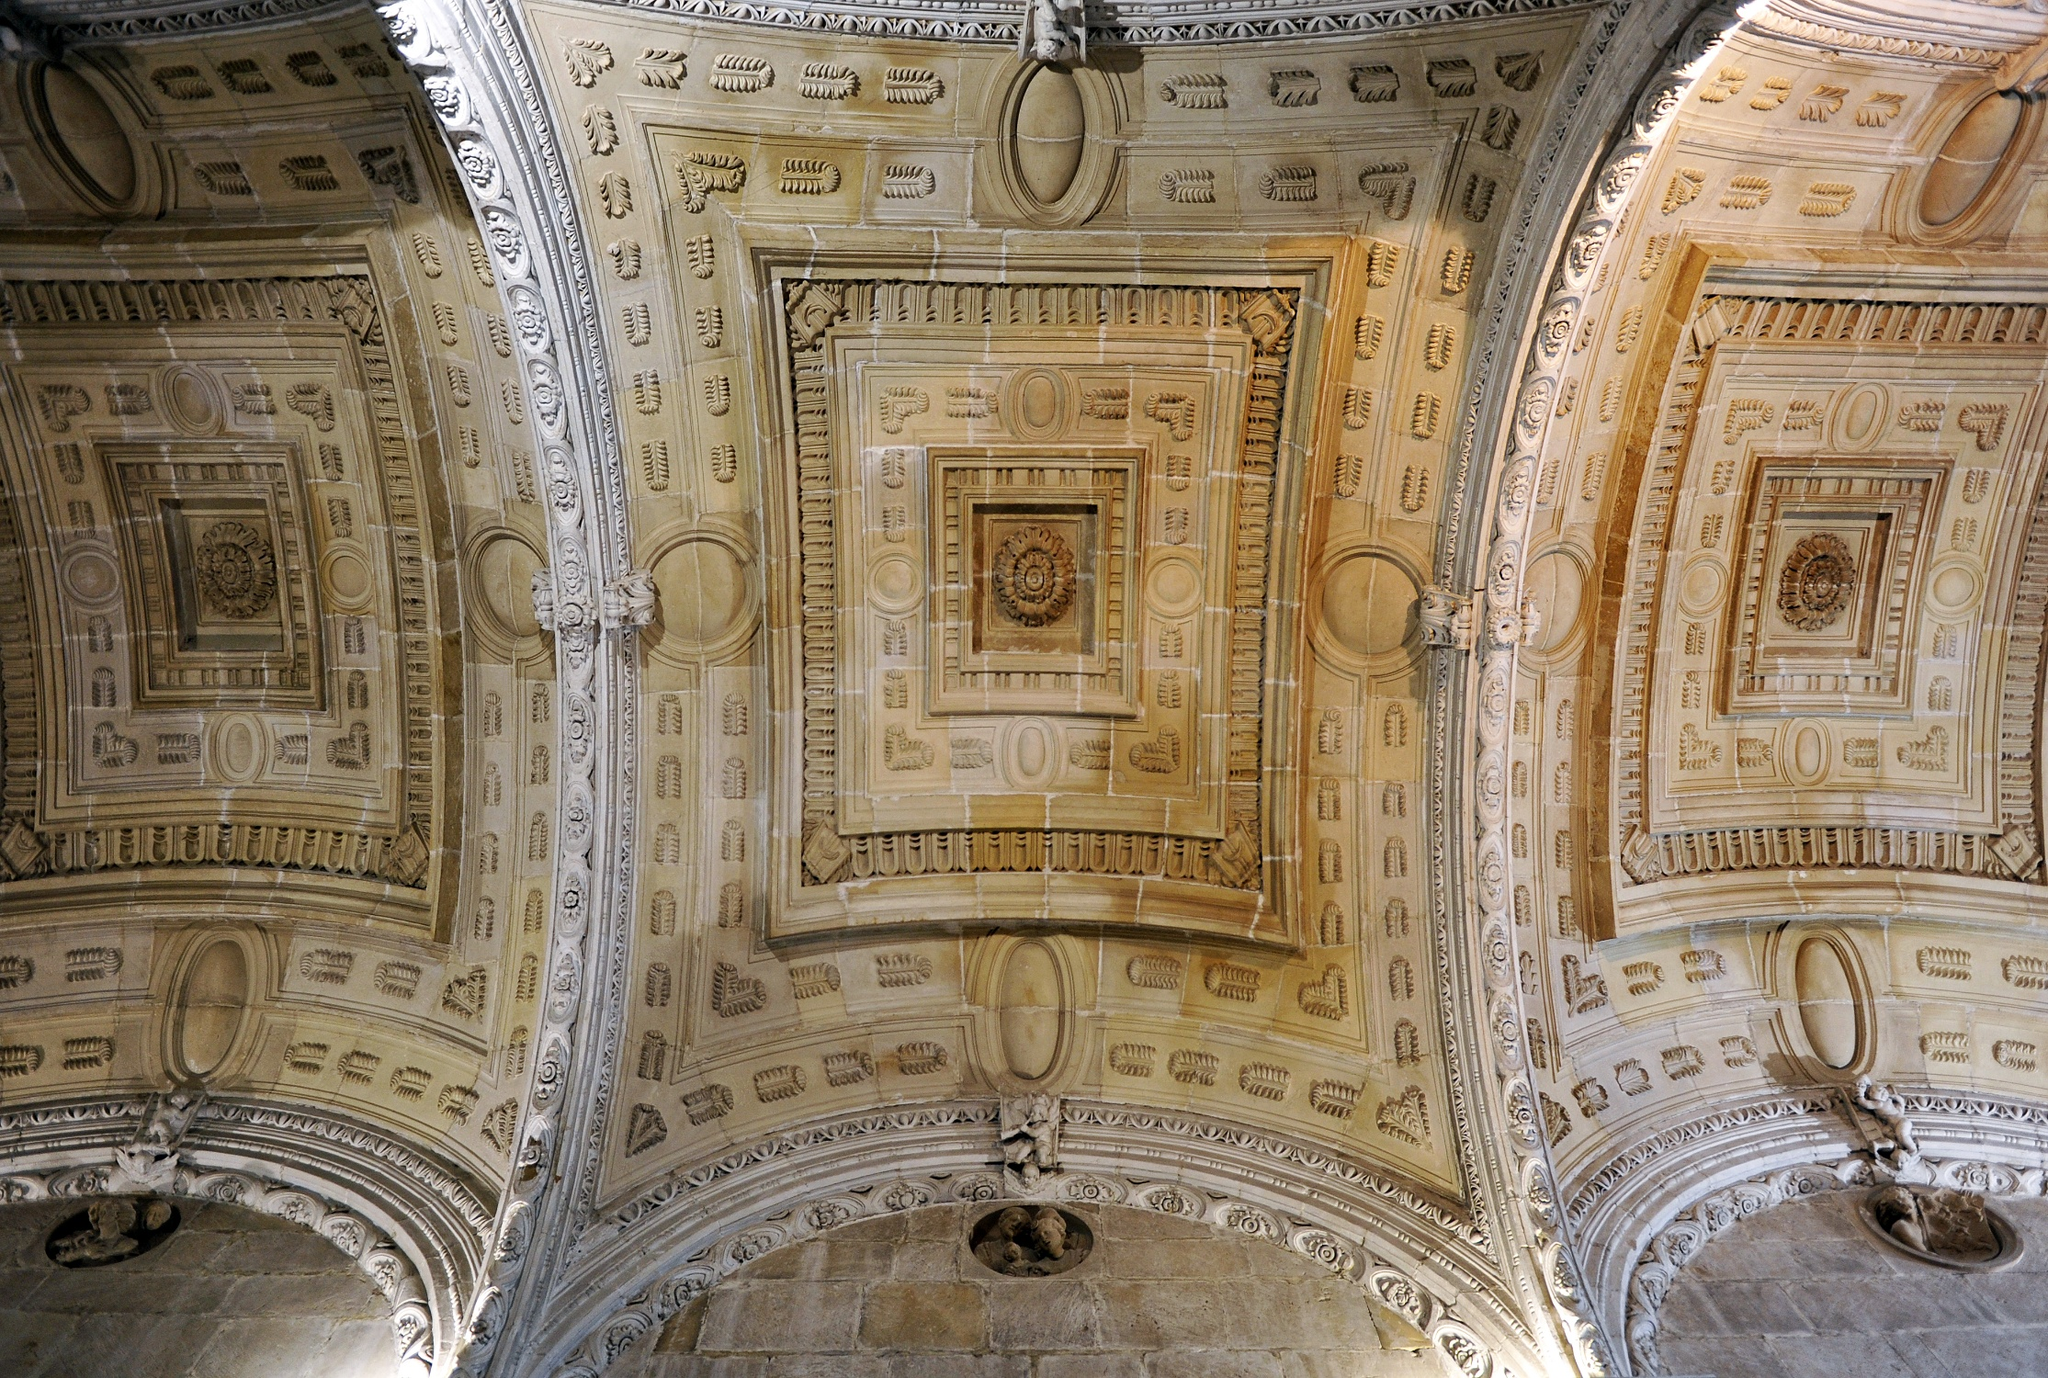Might this location hold any historical treasures? Given the elaborate and majestic design of the ceiling, it is possible that this location holds historical treasures. Grand buildings with such intricate decor were often home to valuable art, documents, and artifacts. Secret chambers or hidden compartments might conceal priceless treasures, from manuscripts detailing historic events to exquisite works of art crafted by renowned artists. This place could be a repository of cultural heritage, preserved through the ages for historians and archaeologists to uncover. 